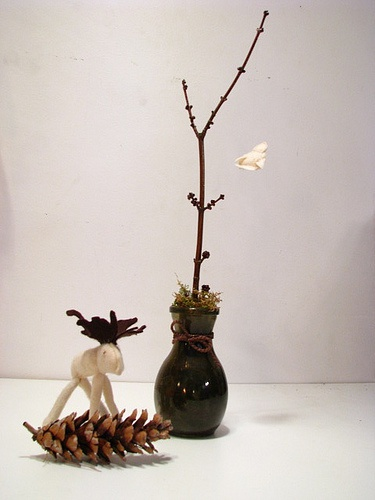Describe the objects in this image and their specific colors. I can see potted plant in lightgray, black, and maroon tones and vase in lightgray, black, maroon, and gray tones in this image. 